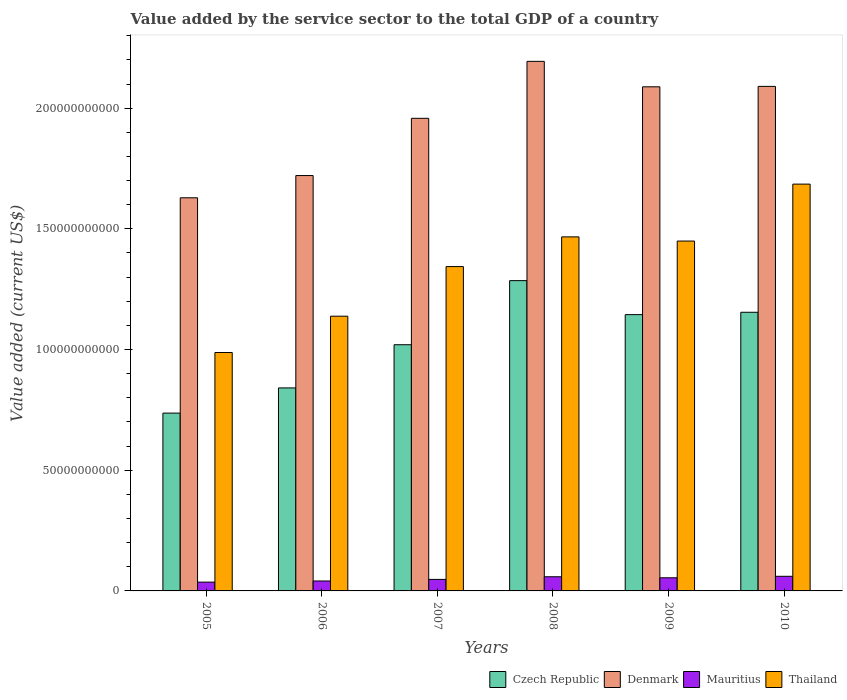How many groups of bars are there?
Provide a succinct answer. 6. Are the number of bars on each tick of the X-axis equal?
Provide a short and direct response. Yes. What is the value added by the service sector to the total GDP in Thailand in 2006?
Make the answer very short. 1.14e+11. Across all years, what is the maximum value added by the service sector to the total GDP in Czech Republic?
Offer a terse response. 1.29e+11. Across all years, what is the minimum value added by the service sector to the total GDP in Thailand?
Your answer should be very brief. 9.88e+1. What is the total value added by the service sector to the total GDP in Mauritius in the graph?
Ensure brevity in your answer.  2.99e+1. What is the difference between the value added by the service sector to the total GDP in Denmark in 2009 and that in 2010?
Keep it short and to the point. -1.75e+08. What is the difference between the value added by the service sector to the total GDP in Czech Republic in 2007 and the value added by the service sector to the total GDP in Mauritius in 2006?
Ensure brevity in your answer.  9.79e+1. What is the average value added by the service sector to the total GDP in Denmark per year?
Offer a terse response. 1.95e+11. In the year 2010, what is the difference between the value added by the service sector to the total GDP in Mauritius and value added by the service sector to the total GDP in Denmark?
Your answer should be very brief. -2.03e+11. What is the ratio of the value added by the service sector to the total GDP in Mauritius in 2007 to that in 2009?
Offer a very short reply. 0.88. Is the value added by the service sector to the total GDP in Denmark in 2006 less than that in 2010?
Offer a terse response. Yes. What is the difference between the highest and the second highest value added by the service sector to the total GDP in Denmark?
Your response must be concise. 1.04e+1. What is the difference between the highest and the lowest value added by the service sector to the total GDP in Denmark?
Offer a terse response. 5.65e+1. Is the sum of the value added by the service sector to the total GDP in Thailand in 2005 and 2008 greater than the maximum value added by the service sector to the total GDP in Mauritius across all years?
Ensure brevity in your answer.  Yes. Is it the case that in every year, the sum of the value added by the service sector to the total GDP in Czech Republic and value added by the service sector to the total GDP in Mauritius is greater than the sum of value added by the service sector to the total GDP in Thailand and value added by the service sector to the total GDP in Denmark?
Your answer should be compact. No. What does the 1st bar from the right in 2005 represents?
Offer a very short reply. Thailand. Is it the case that in every year, the sum of the value added by the service sector to the total GDP in Czech Republic and value added by the service sector to the total GDP in Mauritius is greater than the value added by the service sector to the total GDP in Thailand?
Provide a succinct answer. No. Are all the bars in the graph horizontal?
Give a very brief answer. No. How many years are there in the graph?
Make the answer very short. 6. What is the difference between two consecutive major ticks on the Y-axis?
Your response must be concise. 5.00e+1. Does the graph contain grids?
Your response must be concise. No. How many legend labels are there?
Provide a succinct answer. 4. What is the title of the graph?
Ensure brevity in your answer.  Value added by the service sector to the total GDP of a country. Does "Paraguay" appear as one of the legend labels in the graph?
Your answer should be very brief. No. What is the label or title of the X-axis?
Offer a terse response. Years. What is the label or title of the Y-axis?
Offer a terse response. Value added (current US$). What is the Value added (current US$) in Czech Republic in 2005?
Give a very brief answer. 7.37e+1. What is the Value added (current US$) in Denmark in 2005?
Offer a very short reply. 1.63e+11. What is the Value added (current US$) in Mauritius in 2005?
Give a very brief answer. 3.65e+09. What is the Value added (current US$) in Thailand in 2005?
Your response must be concise. 9.88e+1. What is the Value added (current US$) of Czech Republic in 2006?
Provide a short and direct response. 8.41e+1. What is the Value added (current US$) in Denmark in 2006?
Offer a terse response. 1.72e+11. What is the Value added (current US$) of Mauritius in 2006?
Provide a succinct answer. 4.12e+09. What is the Value added (current US$) in Thailand in 2006?
Give a very brief answer. 1.14e+11. What is the Value added (current US$) of Czech Republic in 2007?
Provide a short and direct response. 1.02e+11. What is the Value added (current US$) in Denmark in 2007?
Ensure brevity in your answer.  1.96e+11. What is the Value added (current US$) of Mauritius in 2007?
Offer a very short reply. 4.77e+09. What is the Value added (current US$) of Thailand in 2007?
Provide a short and direct response. 1.34e+11. What is the Value added (current US$) of Czech Republic in 2008?
Offer a terse response. 1.29e+11. What is the Value added (current US$) in Denmark in 2008?
Give a very brief answer. 2.19e+11. What is the Value added (current US$) in Mauritius in 2008?
Offer a very short reply. 5.87e+09. What is the Value added (current US$) in Thailand in 2008?
Keep it short and to the point. 1.47e+11. What is the Value added (current US$) in Czech Republic in 2009?
Offer a very short reply. 1.14e+11. What is the Value added (current US$) of Denmark in 2009?
Keep it short and to the point. 2.09e+11. What is the Value added (current US$) of Mauritius in 2009?
Your response must be concise. 5.44e+09. What is the Value added (current US$) in Thailand in 2009?
Keep it short and to the point. 1.45e+11. What is the Value added (current US$) in Czech Republic in 2010?
Your answer should be compact. 1.15e+11. What is the Value added (current US$) in Denmark in 2010?
Make the answer very short. 2.09e+11. What is the Value added (current US$) in Mauritius in 2010?
Offer a terse response. 6.06e+09. What is the Value added (current US$) in Thailand in 2010?
Give a very brief answer. 1.69e+11. Across all years, what is the maximum Value added (current US$) in Czech Republic?
Keep it short and to the point. 1.29e+11. Across all years, what is the maximum Value added (current US$) of Denmark?
Make the answer very short. 2.19e+11. Across all years, what is the maximum Value added (current US$) of Mauritius?
Make the answer very short. 6.06e+09. Across all years, what is the maximum Value added (current US$) of Thailand?
Your response must be concise. 1.69e+11. Across all years, what is the minimum Value added (current US$) in Czech Republic?
Your answer should be compact. 7.37e+1. Across all years, what is the minimum Value added (current US$) in Denmark?
Your answer should be very brief. 1.63e+11. Across all years, what is the minimum Value added (current US$) in Mauritius?
Make the answer very short. 3.65e+09. Across all years, what is the minimum Value added (current US$) of Thailand?
Your answer should be very brief. 9.88e+1. What is the total Value added (current US$) in Czech Republic in the graph?
Offer a terse response. 6.18e+11. What is the total Value added (current US$) of Denmark in the graph?
Provide a succinct answer. 1.17e+12. What is the total Value added (current US$) of Mauritius in the graph?
Give a very brief answer. 2.99e+1. What is the total Value added (current US$) of Thailand in the graph?
Your response must be concise. 8.07e+11. What is the difference between the Value added (current US$) in Czech Republic in 2005 and that in 2006?
Your answer should be compact. -1.04e+1. What is the difference between the Value added (current US$) of Denmark in 2005 and that in 2006?
Your response must be concise. -9.21e+09. What is the difference between the Value added (current US$) in Mauritius in 2005 and that in 2006?
Give a very brief answer. -4.71e+08. What is the difference between the Value added (current US$) of Thailand in 2005 and that in 2006?
Give a very brief answer. -1.50e+1. What is the difference between the Value added (current US$) in Czech Republic in 2005 and that in 2007?
Your answer should be compact. -2.83e+1. What is the difference between the Value added (current US$) of Denmark in 2005 and that in 2007?
Ensure brevity in your answer.  -3.29e+1. What is the difference between the Value added (current US$) in Mauritius in 2005 and that in 2007?
Keep it short and to the point. -1.12e+09. What is the difference between the Value added (current US$) of Thailand in 2005 and that in 2007?
Give a very brief answer. -3.56e+1. What is the difference between the Value added (current US$) in Czech Republic in 2005 and that in 2008?
Make the answer very short. -5.49e+1. What is the difference between the Value added (current US$) of Denmark in 2005 and that in 2008?
Ensure brevity in your answer.  -5.65e+1. What is the difference between the Value added (current US$) of Mauritius in 2005 and that in 2008?
Your response must be concise. -2.22e+09. What is the difference between the Value added (current US$) of Thailand in 2005 and that in 2008?
Your answer should be compact. -4.79e+1. What is the difference between the Value added (current US$) in Czech Republic in 2005 and that in 2009?
Keep it short and to the point. -4.08e+1. What is the difference between the Value added (current US$) of Denmark in 2005 and that in 2009?
Your response must be concise. -4.60e+1. What is the difference between the Value added (current US$) in Mauritius in 2005 and that in 2009?
Your response must be concise. -1.79e+09. What is the difference between the Value added (current US$) of Thailand in 2005 and that in 2009?
Provide a succinct answer. -4.62e+1. What is the difference between the Value added (current US$) of Czech Republic in 2005 and that in 2010?
Provide a short and direct response. -4.18e+1. What is the difference between the Value added (current US$) in Denmark in 2005 and that in 2010?
Your response must be concise. -4.62e+1. What is the difference between the Value added (current US$) of Mauritius in 2005 and that in 2010?
Your response must be concise. -2.41e+09. What is the difference between the Value added (current US$) of Thailand in 2005 and that in 2010?
Provide a succinct answer. -6.98e+1. What is the difference between the Value added (current US$) in Czech Republic in 2006 and that in 2007?
Provide a short and direct response. -1.79e+1. What is the difference between the Value added (current US$) in Denmark in 2006 and that in 2007?
Provide a succinct answer. -2.37e+1. What is the difference between the Value added (current US$) of Mauritius in 2006 and that in 2007?
Provide a short and direct response. -6.53e+08. What is the difference between the Value added (current US$) in Thailand in 2006 and that in 2007?
Provide a short and direct response. -2.06e+1. What is the difference between the Value added (current US$) of Czech Republic in 2006 and that in 2008?
Give a very brief answer. -4.44e+1. What is the difference between the Value added (current US$) in Denmark in 2006 and that in 2008?
Ensure brevity in your answer.  -4.73e+1. What is the difference between the Value added (current US$) of Mauritius in 2006 and that in 2008?
Offer a terse response. -1.75e+09. What is the difference between the Value added (current US$) in Thailand in 2006 and that in 2008?
Give a very brief answer. -3.29e+1. What is the difference between the Value added (current US$) in Czech Republic in 2006 and that in 2009?
Your response must be concise. -3.04e+1. What is the difference between the Value added (current US$) in Denmark in 2006 and that in 2009?
Offer a terse response. -3.68e+1. What is the difference between the Value added (current US$) of Mauritius in 2006 and that in 2009?
Provide a short and direct response. -1.32e+09. What is the difference between the Value added (current US$) in Thailand in 2006 and that in 2009?
Your answer should be very brief. -3.11e+1. What is the difference between the Value added (current US$) of Czech Republic in 2006 and that in 2010?
Your answer should be compact. -3.13e+1. What is the difference between the Value added (current US$) of Denmark in 2006 and that in 2010?
Your answer should be very brief. -3.69e+1. What is the difference between the Value added (current US$) of Mauritius in 2006 and that in 2010?
Make the answer very short. -1.94e+09. What is the difference between the Value added (current US$) of Thailand in 2006 and that in 2010?
Give a very brief answer. -5.47e+1. What is the difference between the Value added (current US$) of Czech Republic in 2007 and that in 2008?
Give a very brief answer. -2.66e+1. What is the difference between the Value added (current US$) of Denmark in 2007 and that in 2008?
Provide a succinct answer. -2.36e+1. What is the difference between the Value added (current US$) of Mauritius in 2007 and that in 2008?
Provide a succinct answer. -1.10e+09. What is the difference between the Value added (current US$) of Thailand in 2007 and that in 2008?
Your answer should be compact. -1.23e+1. What is the difference between the Value added (current US$) of Czech Republic in 2007 and that in 2009?
Ensure brevity in your answer.  -1.25e+1. What is the difference between the Value added (current US$) in Denmark in 2007 and that in 2009?
Your response must be concise. -1.31e+1. What is the difference between the Value added (current US$) in Mauritius in 2007 and that in 2009?
Give a very brief answer. -6.64e+08. What is the difference between the Value added (current US$) of Thailand in 2007 and that in 2009?
Your answer should be very brief. -1.06e+1. What is the difference between the Value added (current US$) of Czech Republic in 2007 and that in 2010?
Provide a short and direct response. -1.34e+1. What is the difference between the Value added (current US$) of Denmark in 2007 and that in 2010?
Ensure brevity in your answer.  -1.32e+1. What is the difference between the Value added (current US$) of Mauritius in 2007 and that in 2010?
Your answer should be very brief. -1.28e+09. What is the difference between the Value added (current US$) in Thailand in 2007 and that in 2010?
Provide a succinct answer. -3.42e+1. What is the difference between the Value added (current US$) in Czech Republic in 2008 and that in 2009?
Offer a very short reply. 1.41e+1. What is the difference between the Value added (current US$) in Denmark in 2008 and that in 2009?
Provide a short and direct response. 1.05e+1. What is the difference between the Value added (current US$) of Mauritius in 2008 and that in 2009?
Provide a succinct answer. 4.33e+08. What is the difference between the Value added (current US$) of Thailand in 2008 and that in 2009?
Offer a terse response. 1.73e+09. What is the difference between the Value added (current US$) of Czech Republic in 2008 and that in 2010?
Your answer should be compact. 1.31e+1. What is the difference between the Value added (current US$) in Denmark in 2008 and that in 2010?
Keep it short and to the point. 1.04e+1. What is the difference between the Value added (current US$) of Mauritius in 2008 and that in 2010?
Offer a very short reply. -1.85e+08. What is the difference between the Value added (current US$) of Thailand in 2008 and that in 2010?
Your response must be concise. -2.19e+1. What is the difference between the Value added (current US$) in Czech Republic in 2009 and that in 2010?
Your answer should be compact. -9.76e+08. What is the difference between the Value added (current US$) of Denmark in 2009 and that in 2010?
Make the answer very short. -1.75e+08. What is the difference between the Value added (current US$) of Mauritius in 2009 and that in 2010?
Make the answer very short. -6.18e+08. What is the difference between the Value added (current US$) in Thailand in 2009 and that in 2010?
Your response must be concise. -2.36e+1. What is the difference between the Value added (current US$) of Czech Republic in 2005 and the Value added (current US$) of Denmark in 2006?
Offer a terse response. -9.84e+1. What is the difference between the Value added (current US$) in Czech Republic in 2005 and the Value added (current US$) in Mauritius in 2006?
Ensure brevity in your answer.  6.96e+1. What is the difference between the Value added (current US$) in Czech Republic in 2005 and the Value added (current US$) in Thailand in 2006?
Keep it short and to the point. -4.01e+1. What is the difference between the Value added (current US$) in Denmark in 2005 and the Value added (current US$) in Mauritius in 2006?
Provide a short and direct response. 1.59e+11. What is the difference between the Value added (current US$) in Denmark in 2005 and the Value added (current US$) in Thailand in 2006?
Keep it short and to the point. 4.91e+1. What is the difference between the Value added (current US$) in Mauritius in 2005 and the Value added (current US$) in Thailand in 2006?
Ensure brevity in your answer.  -1.10e+11. What is the difference between the Value added (current US$) in Czech Republic in 2005 and the Value added (current US$) in Denmark in 2007?
Offer a terse response. -1.22e+11. What is the difference between the Value added (current US$) in Czech Republic in 2005 and the Value added (current US$) in Mauritius in 2007?
Offer a very short reply. 6.89e+1. What is the difference between the Value added (current US$) of Czech Republic in 2005 and the Value added (current US$) of Thailand in 2007?
Offer a very short reply. -6.07e+1. What is the difference between the Value added (current US$) in Denmark in 2005 and the Value added (current US$) in Mauritius in 2007?
Offer a terse response. 1.58e+11. What is the difference between the Value added (current US$) in Denmark in 2005 and the Value added (current US$) in Thailand in 2007?
Ensure brevity in your answer.  2.85e+1. What is the difference between the Value added (current US$) in Mauritius in 2005 and the Value added (current US$) in Thailand in 2007?
Give a very brief answer. -1.31e+11. What is the difference between the Value added (current US$) in Czech Republic in 2005 and the Value added (current US$) in Denmark in 2008?
Offer a very short reply. -1.46e+11. What is the difference between the Value added (current US$) in Czech Republic in 2005 and the Value added (current US$) in Mauritius in 2008?
Keep it short and to the point. 6.78e+1. What is the difference between the Value added (current US$) in Czech Republic in 2005 and the Value added (current US$) in Thailand in 2008?
Provide a succinct answer. -7.30e+1. What is the difference between the Value added (current US$) in Denmark in 2005 and the Value added (current US$) in Mauritius in 2008?
Offer a terse response. 1.57e+11. What is the difference between the Value added (current US$) of Denmark in 2005 and the Value added (current US$) of Thailand in 2008?
Your answer should be compact. 1.62e+1. What is the difference between the Value added (current US$) of Mauritius in 2005 and the Value added (current US$) of Thailand in 2008?
Ensure brevity in your answer.  -1.43e+11. What is the difference between the Value added (current US$) of Czech Republic in 2005 and the Value added (current US$) of Denmark in 2009?
Offer a terse response. -1.35e+11. What is the difference between the Value added (current US$) in Czech Republic in 2005 and the Value added (current US$) in Mauritius in 2009?
Your answer should be compact. 6.82e+1. What is the difference between the Value added (current US$) in Czech Republic in 2005 and the Value added (current US$) in Thailand in 2009?
Offer a very short reply. -7.13e+1. What is the difference between the Value added (current US$) in Denmark in 2005 and the Value added (current US$) in Mauritius in 2009?
Your answer should be very brief. 1.57e+11. What is the difference between the Value added (current US$) in Denmark in 2005 and the Value added (current US$) in Thailand in 2009?
Offer a terse response. 1.79e+1. What is the difference between the Value added (current US$) in Mauritius in 2005 and the Value added (current US$) in Thailand in 2009?
Provide a short and direct response. -1.41e+11. What is the difference between the Value added (current US$) in Czech Republic in 2005 and the Value added (current US$) in Denmark in 2010?
Ensure brevity in your answer.  -1.35e+11. What is the difference between the Value added (current US$) of Czech Republic in 2005 and the Value added (current US$) of Mauritius in 2010?
Make the answer very short. 6.76e+1. What is the difference between the Value added (current US$) of Czech Republic in 2005 and the Value added (current US$) of Thailand in 2010?
Provide a short and direct response. -9.49e+1. What is the difference between the Value added (current US$) of Denmark in 2005 and the Value added (current US$) of Mauritius in 2010?
Give a very brief answer. 1.57e+11. What is the difference between the Value added (current US$) in Denmark in 2005 and the Value added (current US$) in Thailand in 2010?
Your answer should be very brief. -5.66e+09. What is the difference between the Value added (current US$) of Mauritius in 2005 and the Value added (current US$) of Thailand in 2010?
Ensure brevity in your answer.  -1.65e+11. What is the difference between the Value added (current US$) of Czech Republic in 2006 and the Value added (current US$) of Denmark in 2007?
Offer a very short reply. -1.12e+11. What is the difference between the Value added (current US$) in Czech Republic in 2006 and the Value added (current US$) in Mauritius in 2007?
Ensure brevity in your answer.  7.93e+1. What is the difference between the Value added (current US$) of Czech Republic in 2006 and the Value added (current US$) of Thailand in 2007?
Your response must be concise. -5.03e+1. What is the difference between the Value added (current US$) of Denmark in 2006 and the Value added (current US$) of Mauritius in 2007?
Give a very brief answer. 1.67e+11. What is the difference between the Value added (current US$) in Denmark in 2006 and the Value added (current US$) in Thailand in 2007?
Your answer should be compact. 3.77e+1. What is the difference between the Value added (current US$) of Mauritius in 2006 and the Value added (current US$) of Thailand in 2007?
Offer a very short reply. -1.30e+11. What is the difference between the Value added (current US$) of Czech Republic in 2006 and the Value added (current US$) of Denmark in 2008?
Keep it short and to the point. -1.35e+11. What is the difference between the Value added (current US$) of Czech Republic in 2006 and the Value added (current US$) of Mauritius in 2008?
Provide a succinct answer. 7.82e+1. What is the difference between the Value added (current US$) in Czech Republic in 2006 and the Value added (current US$) in Thailand in 2008?
Provide a succinct answer. -6.26e+1. What is the difference between the Value added (current US$) of Denmark in 2006 and the Value added (current US$) of Mauritius in 2008?
Your answer should be compact. 1.66e+11. What is the difference between the Value added (current US$) of Denmark in 2006 and the Value added (current US$) of Thailand in 2008?
Offer a very short reply. 2.54e+1. What is the difference between the Value added (current US$) of Mauritius in 2006 and the Value added (current US$) of Thailand in 2008?
Ensure brevity in your answer.  -1.43e+11. What is the difference between the Value added (current US$) in Czech Republic in 2006 and the Value added (current US$) in Denmark in 2009?
Give a very brief answer. -1.25e+11. What is the difference between the Value added (current US$) of Czech Republic in 2006 and the Value added (current US$) of Mauritius in 2009?
Ensure brevity in your answer.  7.87e+1. What is the difference between the Value added (current US$) in Czech Republic in 2006 and the Value added (current US$) in Thailand in 2009?
Provide a short and direct response. -6.08e+1. What is the difference between the Value added (current US$) of Denmark in 2006 and the Value added (current US$) of Mauritius in 2009?
Give a very brief answer. 1.67e+11. What is the difference between the Value added (current US$) in Denmark in 2006 and the Value added (current US$) in Thailand in 2009?
Ensure brevity in your answer.  2.71e+1. What is the difference between the Value added (current US$) of Mauritius in 2006 and the Value added (current US$) of Thailand in 2009?
Keep it short and to the point. -1.41e+11. What is the difference between the Value added (current US$) of Czech Republic in 2006 and the Value added (current US$) of Denmark in 2010?
Give a very brief answer. -1.25e+11. What is the difference between the Value added (current US$) of Czech Republic in 2006 and the Value added (current US$) of Mauritius in 2010?
Provide a short and direct response. 7.80e+1. What is the difference between the Value added (current US$) of Czech Republic in 2006 and the Value added (current US$) of Thailand in 2010?
Your response must be concise. -8.44e+1. What is the difference between the Value added (current US$) in Denmark in 2006 and the Value added (current US$) in Mauritius in 2010?
Your answer should be very brief. 1.66e+11. What is the difference between the Value added (current US$) in Denmark in 2006 and the Value added (current US$) in Thailand in 2010?
Provide a short and direct response. 3.55e+09. What is the difference between the Value added (current US$) in Mauritius in 2006 and the Value added (current US$) in Thailand in 2010?
Your answer should be very brief. -1.64e+11. What is the difference between the Value added (current US$) in Czech Republic in 2007 and the Value added (current US$) in Denmark in 2008?
Make the answer very short. -1.17e+11. What is the difference between the Value added (current US$) of Czech Republic in 2007 and the Value added (current US$) of Mauritius in 2008?
Your answer should be very brief. 9.61e+1. What is the difference between the Value added (current US$) in Czech Republic in 2007 and the Value added (current US$) in Thailand in 2008?
Provide a succinct answer. -4.47e+1. What is the difference between the Value added (current US$) of Denmark in 2007 and the Value added (current US$) of Mauritius in 2008?
Provide a succinct answer. 1.90e+11. What is the difference between the Value added (current US$) of Denmark in 2007 and the Value added (current US$) of Thailand in 2008?
Provide a short and direct response. 4.91e+1. What is the difference between the Value added (current US$) in Mauritius in 2007 and the Value added (current US$) in Thailand in 2008?
Provide a succinct answer. -1.42e+11. What is the difference between the Value added (current US$) of Czech Republic in 2007 and the Value added (current US$) of Denmark in 2009?
Provide a short and direct response. -1.07e+11. What is the difference between the Value added (current US$) of Czech Republic in 2007 and the Value added (current US$) of Mauritius in 2009?
Make the answer very short. 9.66e+1. What is the difference between the Value added (current US$) in Czech Republic in 2007 and the Value added (current US$) in Thailand in 2009?
Provide a short and direct response. -4.30e+1. What is the difference between the Value added (current US$) of Denmark in 2007 and the Value added (current US$) of Mauritius in 2009?
Your answer should be very brief. 1.90e+11. What is the difference between the Value added (current US$) in Denmark in 2007 and the Value added (current US$) in Thailand in 2009?
Provide a succinct answer. 5.08e+1. What is the difference between the Value added (current US$) in Mauritius in 2007 and the Value added (current US$) in Thailand in 2009?
Offer a terse response. -1.40e+11. What is the difference between the Value added (current US$) in Czech Republic in 2007 and the Value added (current US$) in Denmark in 2010?
Your response must be concise. -1.07e+11. What is the difference between the Value added (current US$) of Czech Republic in 2007 and the Value added (current US$) of Mauritius in 2010?
Your response must be concise. 9.59e+1. What is the difference between the Value added (current US$) in Czech Republic in 2007 and the Value added (current US$) in Thailand in 2010?
Offer a terse response. -6.65e+1. What is the difference between the Value added (current US$) of Denmark in 2007 and the Value added (current US$) of Mauritius in 2010?
Your answer should be compact. 1.90e+11. What is the difference between the Value added (current US$) in Denmark in 2007 and the Value added (current US$) in Thailand in 2010?
Provide a short and direct response. 2.73e+1. What is the difference between the Value added (current US$) in Mauritius in 2007 and the Value added (current US$) in Thailand in 2010?
Offer a terse response. -1.64e+11. What is the difference between the Value added (current US$) of Czech Republic in 2008 and the Value added (current US$) of Denmark in 2009?
Provide a succinct answer. -8.03e+1. What is the difference between the Value added (current US$) of Czech Republic in 2008 and the Value added (current US$) of Mauritius in 2009?
Ensure brevity in your answer.  1.23e+11. What is the difference between the Value added (current US$) in Czech Republic in 2008 and the Value added (current US$) in Thailand in 2009?
Give a very brief answer. -1.64e+1. What is the difference between the Value added (current US$) of Denmark in 2008 and the Value added (current US$) of Mauritius in 2009?
Your answer should be very brief. 2.14e+11. What is the difference between the Value added (current US$) of Denmark in 2008 and the Value added (current US$) of Thailand in 2009?
Your response must be concise. 7.44e+1. What is the difference between the Value added (current US$) in Mauritius in 2008 and the Value added (current US$) in Thailand in 2009?
Keep it short and to the point. -1.39e+11. What is the difference between the Value added (current US$) of Czech Republic in 2008 and the Value added (current US$) of Denmark in 2010?
Give a very brief answer. -8.05e+1. What is the difference between the Value added (current US$) of Czech Republic in 2008 and the Value added (current US$) of Mauritius in 2010?
Make the answer very short. 1.22e+11. What is the difference between the Value added (current US$) in Czech Republic in 2008 and the Value added (current US$) in Thailand in 2010?
Provide a succinct answer. -4.00e+1. What is the difference between the Value added (current US$) of Denmark in 2008 and the Value added (current US$) of Mauritius in 2010?
Ensure brevity in your answer.  2.13e+11. What is the difference between the Value added (current US$) of Denmark in 2008 and the Value added (current US$) of Thailand in 2010?
Your answer should be very brief. 5.09e+1. What is the difference between the Value added (current US$) of Mauritius in 2008 and the Value added (current US$) of Thailand in 2010?
Offer a very short reply. -1.63e+11. What is the difference between the Value added (current US$) of Czech Republic in 2009 and the Value added (current US$) of Denmark in 2010?
Keep it short and to the point. -9.46e+1. What is the difference between the Value added (current US$) of Czech Republic in 2009 and the Value added (current US$) of Mauritius in 2010?
Offer a terse response. 1.08e+11. What is the difference between the Value added (current US$) of Czech Republic in 2009 and the Value added (current US$) of Thailand in 2010?
Make the answer very short. -5.41e+1. What is the difference between the Value added (current US$) of Denmark in 2009 and the Value added (current US$) of Mauritius in 2010?
Your answer should be compact. 2.03e+11. What is the difference between the Value added (current US$) in Denmark in 2009 and the Value added (current US$) in Thailand in 2010?
Provide a short and direct response. 4.03e+1. What is the difference between the Value added (current US$) in Mauritius in 2009 and the Value added (current US$) in Thailand in 2010?
Ensure brevity in your answer.  -1.63e+11. What is the average Value added (current US$) in Czech Republic per year?
Offer a very short reply. 1.03e+11. What is the average Value added (current US$) of Denmark per year?
Offer a very short reply. 1.95e+11. What is the average Value added (current US$) of Mauritius per year?
Your response must be concise. 4.98e+09. What is the average Value added (current US$) of Thailand per year?
Ensure brevity in your answer.  1.35e+11. In the year 2005, what is the difference between the Value added (current US$) of Czech Republic and Value added (current US$) of Denmark?
Provide a succinct answer. -8.92e+1. In the year 2005, what is the difference between the Value added (current US$) of Czech Republic and Value added (current US$) of Mauritius?
Provide a short and direct response. 7.00e+1. In the year 2005, what is the difference between the Value added (current US$) in Czech Republic and Value added (current US$) in Thailand?
Make the answer very short. -2.51e+1. In the year 2005, what is the difference between the Value added (current US$) of Denmark and Value added (current US$) of Mauritius?
Keep it short and to the point. 1.59e+11. In the year 2005, what is the difference between the Value added (current US$) of Denmark and Value added (current US$) of Thailand?
Your answer should be very brief. 6.41e+1. In the year 2005, what is the difference between the Value added (current US$) of Mauritius and Value added (current US$) of Thailand?
Your answer should be compact. -9.51e+1. In the year 2006, what is the difference between the Value added (current US$) in Czech Republic and Value added (current US$) in Denmark?
Your answer should be very brief. -8.80e+1. In the year 2006, what is the difference between the Value added (current US$) in Czech Republic and Value added (current US$) in Mauritius?
Provide a succinct answer. 8.00e+1. In the year 2006, what is the difference between the Value added (current US$) in Czech Republic and Value added (current US$) in Thailand?
Your answer should be compact. -2.97e+1. In the year 2006, what is the difference between the Value added (current US$) of Denmark and Value added (current US$) of Mauritius?
Provide a short and direct response. 1.68e+11. In the year 2006, what is the difference between the Value added (current US$) in Denmark and Value added (current US$) in Thailand?
Offer a terse response. 5.83e+1. In the year 2006, what is the difference between the Value added (current US$) of Mauritius and Value added (current US$) of Thailand?
Offer a terse response. -1.10e+11. In the year 2007, what is the difference between the Value added (current US$) of Czech Republic and Value added (current US$) of Denmark?
Provide a short and direct response. -9.38e+1. In the year 2007, what is the difference between the Value added (current US$) in Czech Republic and Value added (current US$) in Mauritius?
Offer a very short reply. 9.72e+1. In the year 2007, what is the difference between the Value added (current US$) in Czech Republic and Value added (current US$) in Thailand?
Your response must be concise. -3.24e+1. In the year 2007, what is the difference between the Value added (current US$) of Denmark and Value added (current US$) of Mauritius?
Make the answer very short. 1.91e+11. In the year 2007, what is the difference between the Value added (current US$) in Denmark and Value added (current US$) in Thailand?
Provide a short and direct response. 6.14e+1. In the year 2007, what is the difference between the Value added (current US$) of Mauritius and Value added (current US$) of Thailand?
Your response must be concise. -1.30e+11. In the year 2008, what is the difference between the Value added (current US$) in Czech Republic and Value added (current US$) in Denmark?
Keep it short and to the point. -9.08e+1. In the year 2008, what is the difference between the Value added (current US$) in Czech Republic and Value added (current US$) in Mauritius?
Your answer should be very brief. 1.23e+11. In the year 2008, what is the difference between the Value added (current US$) in Czech Republic and Value added (current US$) in Thailand?
Provide a succinct answer. -1.81e+1. In the year 2008, what is the difference between the Value added (current US$) of Denmark and Value added (current US$) of Mauritius?
Your answer should be very brief. 2.14e+11. In the year 2008, what is the difference between the Value added (current US$) of Denmark and Value added (current US$) of Thailand?
Keep it short and to the point. 7.27e+1. In the year 2008, what is the difference between the Value added (current US$) in Mauritius and Value added (current US$) in Thailand?
Make the answer very short. -1.41e+11. In the year 2009, what is the difference between the Value added (current US$) of Czech Republic and Value added (current US$) of Denmark?
Offer a very short reply. -9.44e+1. In the year 2009, what is the difference between the Value added (current US$) of Czech Republic and Value added (current US$) of Mauritius?
Give a very brief answer. 1.09e+11. In the year 2009, what is the difference between the Value added (current US$) in Czech Republic and Value added (current US$) in Thailand?
Keep it short and to the point. -3.05e+1. In the year 2009, what is the difference between the Value added (current US$) of Denmark and Value added (current US$) of Mauritius?
Make the answer very short. 2.03e+11. In the year 2009, what is the difference between the Value added (current US$) in Denmark and Value added (current US$) in Thailand?
Give a very brief answer. 6.39e+1. In the year 2009, what is the difference between the Value added (current US$) of Mauritius and Value added (current US$) of Thailand?
Your answer should be very brief. -1.40e+11. In the year 2010, what is the difference between the Value added (current US$) in Czech Republic and Value added (current US$) in Denmark?
Give a very brief answer. -9.36e+1. In the year 2010, what is the difference between the Value added (current US$) of Czech Republic and Value added (current US$) of Mauritius?
Your response must be concise. 1.09e+11. In the year 2010, what is the difference between the Value added (current US$) of Czech Republic and Value added (current US$) of Thailand?
Your answer should be very brief. -5.31e+1. In the year 2010, what is the difference between the Value added (current US$) in Denmark and Value added (current US$) in Mauritius?
Your response must be concise. 2.03e+11. In the year 2010, what is the difference between the Value added (current US$) in Denmark and Value added (current US$) in Thailand?
Offer a very short reply. 4.05e+1. In the year 2010, what is the difference between the Value added (current US$) of Mauritius and Value added (current US$) of Thailand?
Make the answer very short. -1.62e+11. What is the ratio of the Value added (current US$) in Czech Republic in 2005 to that in 2006?
Give a very brief answer. 0.88. What is the ratio of the Value added (current US$) in Denmark in 2005 to that in 2006?
Offer a very short reply. 0.95. What is the ratio of the Value added (current US$) in Mauritius in 2005 to that in 2006?
Ensure brevity in your answer.  0.89. What is the ratio of the Value added (current US$) of Thailand in 2005 to that in 2006?
Offer a terse response. 0.87. What is the ratio of the Value added (current US$) of Czech Republic in 2005 to that in 2007?
Make the answer very short. 0.72. What is the ratio of the Value added (current US$) in Denmark in 2005 to that in 2007?
Your answer should be compact. 0.83. What is the ratio of the Value added (current US$) of Mauritius in 2005 to that in 2007?
Ensure brevity in your answer.  0.76. What is the ratio of the Value added (current US$) of Thailand in 2005 to that in 2007?
Keep it short and to the point. 0.74. What is the ratio of the Value added (current US$) in Czech Republic in 2005 to that in 2008?
Provide a short and direct response. 0.57. What is the ratio of the Value added (current US$) of Denmark in 2005 to that in 2008?
Your answer should be very brief. 0.74. What is the ratio of the Value added (current US$) in Mauritius in 2005 to that in 2008?
Offer a very short reply. 0.62. What is the ratio of the Value added (current US$) of Thailand in 2005 to that in 2008?
Provide a succinct answer. 0.67. What is the ratio of the Value added (current US$) of Czech Republic in 2005 to that in 2009?
Your answer should be very brief. 0.64. What is the ratio of the Value added (current US$) in Denmark in 2005 to that in 2009?
Make the answer very short. 0.78. What is the ratio of the Value added (current US$) of Mauritius in 2005 to that in 2009?
Make the answer very short. 0.67. What is the ratio of the Value added (current US$) of Thailand in 2005 to that in 2009?
Make the answer very short. 0.68. What is the ratio of the Value added (current US$) in Czech Republic in 2005 to that in 2010?
Keep it short and to the point. 0.64. What is the ratio of the Value added (current US$) of Denmark in 2005 to that in 2010?
Your answer should be very brief. 0.78. What is the ratio of the Value added (current US$) of Mauritius in 2005 to that in 2010?
Keep it short and to the point. 0.6. What is the ratio of the Value added (current US$) in Thailand in 2005 to that in 2010?
Provide a short and direct response. 0.59. What is the ratio of the Value added (current US$) of Czech Republic in 2006 to that in 2007?
Make the answer very short. 0.82. What is the ratio of the Value added (current US$) of Denmark in 2006 to that in 2007?
Ensure brevity in your answer.  0.88. What is the ratio of the Value added (current US$) of Mauritius in 2006 to that in 2007?
Keep it short and to the point. 0.86. What is the ratio of the Value added (current US$) of Thailand in 2006 to that in 2007?
Your answer should be very brief. 0.85. What is the ratio of the Value added (current US$) in Czech Republic in 2006 to that in 2008?
Offer a terse response. 0.65. What is the ratio of the Value added (current US$) of Denmark in 2006 to that in 2008?
Make the answer very short. 0.78. What is the ratio of the Value added (current US$) in Mauritius in 2006 to that in 2008?
Provide a succinct answer. 0.7. What is the ratio of the Value added (current US$) of Thailand in 2006 to that in 2008?
Your answer should be compact. 0.78. What is the ratio of the Value added (current US$) in Czech Republic in 2006 to that in 2009?
Give a very brief answer. 0.73. What is the ratio of the Value added (current US$) in Denmark in 2006 to that in 2009?
Ensure brevity in your answer.  0.82. What is the ratio of the Value added (current US$) of Mauritius in 2006 to that in 2009?
Ensure brevity in your answer.  0.76. What is the ratio of the Value added (current US$) of Thailand in 2006 to that in 2009?
Offer a very short reply. 0.79. What is the ratio of the Value added (current US$) of Czech Republic in 2006 to that in 2010?
Offer a very short reply. 0.73. What is the ratio of the Value added (current US$) of Denmark in 2006 to that in 2010?
Keep it short and to the point. 0.82. What is the ratio of the Value added (current US$) in Mauritius in 2006 to that in 2010?
Provide a succinct answer. 0.68. What is the ratio of the Value added (current US$) in Thailand in 2006 to that in 2010?
Keep it short and to the point. 0.68. What is the ratio of the Value added (current US$) in Czech Republic in 2007 to that in 2008?
Offer a very short reply. 0.79. What is the ratio of the Value added (current US$) of Denmark in 2007 to that in 2008?
Offer a very short reply. 0.89. What is the ratio of the Value added (current US$) of Mauritius in 2007 to that in 2008?
Ensure brevity in your answer.  0.81. What is the ratio of the Value added (current US$) in Thailand in 2007 to that in 2008?
Make the answer very short. 0.92. What is the ratio of the Value added (current US$) of Czech Republic in 2007 to that in 2009?
Your answer should be compact. 0.89. What is the ratio of the Value added (current US$) in Denmark in 2007 to that in 2009?
Your answer should be very brief. 0.94. What is the ratio of the Value added (current US$) of Mauritius in 2007 to that in 2009?
Ensure brevity in your answer.  0.88. What is the ratio of the Value added (current US$) in Thailand in 2007 to that in 2009?
Provide a succinct answer. 0.93. What is the ratio of the Value added (current US$) of Czech Republic in 2007 to that in 2010?
Your answer should be very brief. 0.88. What is the ratio of the Value added (current US$) in Denmark in 2007 to that in 2010?
Ensure brevity in your answer.  0.94. What is the ratio of the Value added (current US$) of Mauritius in 2007 to that in 2010?
Your answer should be compact. 0.79. What is the ratio of the Value added (current US$) in Thailand in 2007 to that in 2010?
Provide a short and direct response. 0.8. What is the ratio of the Value added (current US$) in Czech Republic in 2008 to that in 2009?
Give a very brief answer. 1.12. What is the ratio of the Value added (current US$) of Denmark in 2008 to that in 2009?
Offer a very short reply. 1.05. What is the ratio of the Value added (current US$) in Mauritius in 2008 to that in 2009?
Keep it short and to the point. 1.08. What is the ratio of the Value added (current US$) in Thailand in 2008 to that in 2009?
Offer a terse response. 1.01. What is the ratio of the Value added (current US$) of Czech Republic in 2008 to that in 2010?
Ensure brevity in your answer.  1.11. What is the ratio of the Value added (current US$) in Denmark in 2008 to that in 2010?
Offer a very short reply. 1.05. What is the ratio of the Value added (current US$) in Mauritius in 2008 to that in 2010?
Ensure brevity in your answer.  0.97. What is the ratio of the Value added (current US$) in Thailand in 2008 to that in 2010?
Ensure brevity in your answer.  0.87. What is the ratio of the Value added (current US$) in Czech Republic in 2009 to that in 2010?
Keep it short and to the point. 0.99. What is the ratio of the Value added (current US$) of Mauritius in 2009 to that in 2010?
Your response must be concise. 0.9. What is the ratio of the Value added (current US$) in Thailand in 2009 to that in 2010?
Your answer should be compact. 0.86. What is the difference between the highest and the second highest Value added (current US$) in Czech Republic?
Make the answer very short. 1.31e+1. What is the difference between the highest and the second highest Value added (current US$) of Denmark?
Your answer should be very brief. 1.04e+1. What is the difference between the highest and the second highest Value added (current US$) of Mauritius?
Give a very brief answer. 1.85e+08. What is the difference between the highest and the second highest Value added (current US$) in Thailand?
Provide a short and direct response. 2.19e+1. What is the difference between the highest and the lowest Value added (current US$) of Czech Republic?
Offer a very short reply. 5.49e+1. What is the difference between the highest and the lowest Value added (current US$) in Denmark?
Make the answer very short. 5.65e+1. What is the difference between the highest and the lowest Value added (current US$) in Mauritius?
Offer a terse response. 2.41e+09. What is the difference between the highest and the lowest Value added (current US$) in Thailand?
Offer a very short reply. 6.98e+1. 